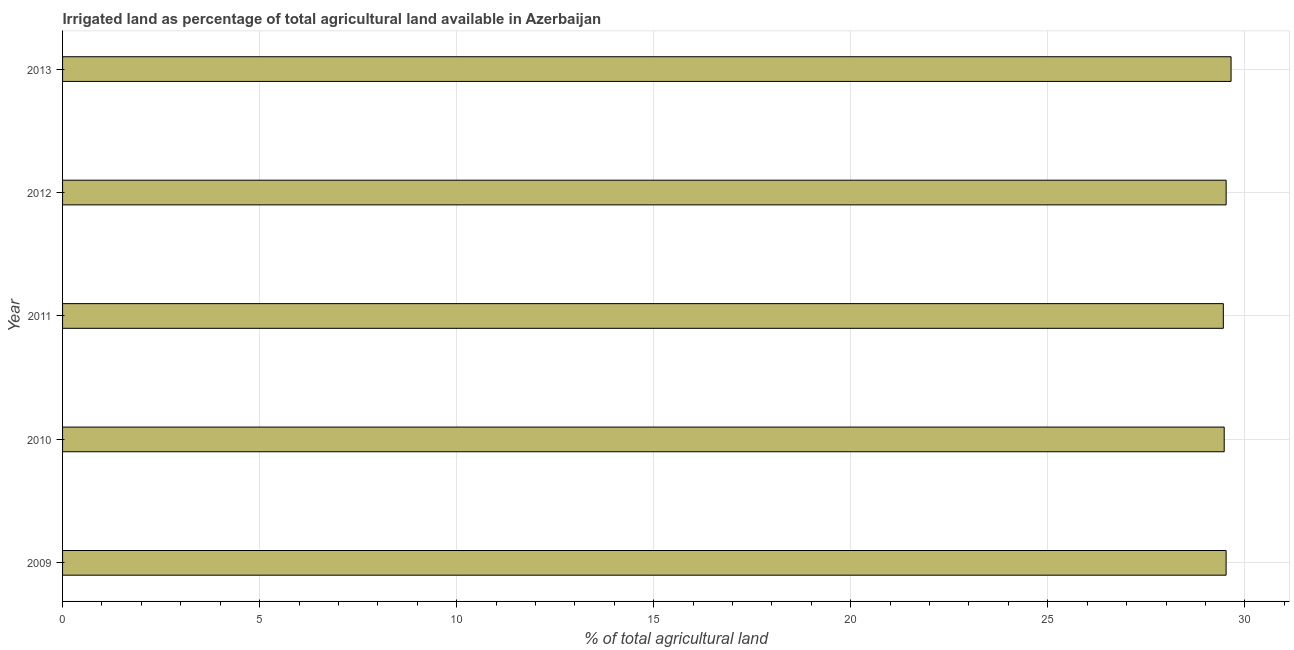Does the graph contain any zero values?
Provide a short and direct response. No. What is the title of the graph?
Give a very brief answer. Irrigated land as percentage of total agricultural land available in Azerbaijan. What is the label or title of the X-axis?
Keep it short and to the point. % of total agricultural land. What is the label or title of the Y-axis?
Provide a short and direct response. Year. What is the percentage of agricultural irrigated land in 2012?
Provide a short and direct response. 29.53. Across all years, what is the maximum percentage of agricultural irrigated land?
Offer a very short reply. 29.65. Across all years, what is the minimum percentage of agricultural irrigated land?
Your response must be concise. 29.45. In which year was the percentage of agricultural irrigated land minimum?
Ensure brevity in your answer.  2011. What is the sum of the percentage of agricultural irrigated land?
Make the answer very short. 147.63. What is the difference between the percentage of agricultural irrigated land in 2012 and 2013?
Your response must be concise. -0.12. What is the average percentage of agricultural irrigated land per year?
Offer a very short reply. 29.53. What is the median percentage of agricultural irrigated land?
Keep it short and to the point. 29.53. In how many years, is the percentage of agricultural irrigated land greater than 9 %?
Ensure brevity in your answer.  5. Do a majority of the years between 2011 and 2010 (inclusive) have percentage of agricultural irrigated land greater than 2 %?
Your response must be concise. No. What is the ratio of the percentage of agricultural irrigated land in 2010 to that in 2012?
Provide a short and direct response. 1. Is the percentage of agricultural irrigated land in 2009 less than that in 2011?
Provide a succinct answer. No. What is the difference between the highest and the lowest percentage of agricultural irrigated land?
Keep it short and to the point. 0.2. Are all the bars in the graph horizontal?
Ensure brevity in your answer.  Yes. How many years are there in the graph?
Ensure brevity in your answer.  5. What is the difference between two consecutive major ticks on the X-axis?
Your answer should be very brief. 5. Are the values on the major ticks of X-axis written in scientific E-notation?
Provide a short and direct response. No. What is the % of total agricultural land of 2009?
Make the answer very short. 29.53. What is the % of total agricultural land of 2010?
Your answer should be very brief. 29.48. What is the % of total agricultural land in 2011?
Make the answer very short. 29.45. What is the % of total agricultural land in 2012?
Give a very brief answer. 29.53. What is the % of total agricultural land of 2013?
Keep it short and to the point. 29.65. What is the difference between the % of total agricultural land in 2009 and 2010?
Your answer should be very brief. 0.05. What is the difference between the % of total agricultural land in 2009 and 2011?
Provide a short and direct response. 0.07. What is the difference between the % of total agricultural land in 2009 and 2012?
Give a very brief answer. -0. What is the difference between the % of total agricultural land in 2009 and 2013?
Ensure brevity in your answer.  -0.13. What is the difference between the % of total agricultural land in 2010 and 2011?
Make the answer very short. 0.02. What is the difference between the % of total agricultural land in 2010 and 2012?
Ensure brevity in your answer.  -0.05. What is the difference between the % of total agricultural land in 2010 and 2013?
Keep it short and to the point. -0.17. What is the difference between the % of total agricultural land in 2011 and 2012?
Keep it short and to the point. -0.07. What is the difference between the % of total agricultural land in 2011 and 2013?
Provide a succinct answer. -0.2. What is the difference between the % of total agricultural land in 2012 and 2013?
Give a very brief answer. -0.12. What is the ratio of the % of total agricultural land in 2009 to that in 2011?
Offer a terse response. 1. What is the ratio of the % of total agricultural land in 2009 to that in 2013?
Make the answer very short. 1. What is the ratio of the % of total agricultural land in 2010 to that in 2013?
Your answer should be compact. 0.99. What is the ratio of the % of total agricultural land in 2011 to that in 2012?
Your answer should be compact. 1. What is the ratio of the % of total agricultural land in 2011 to that in 2013?
Make the answer very short. 0.99. 